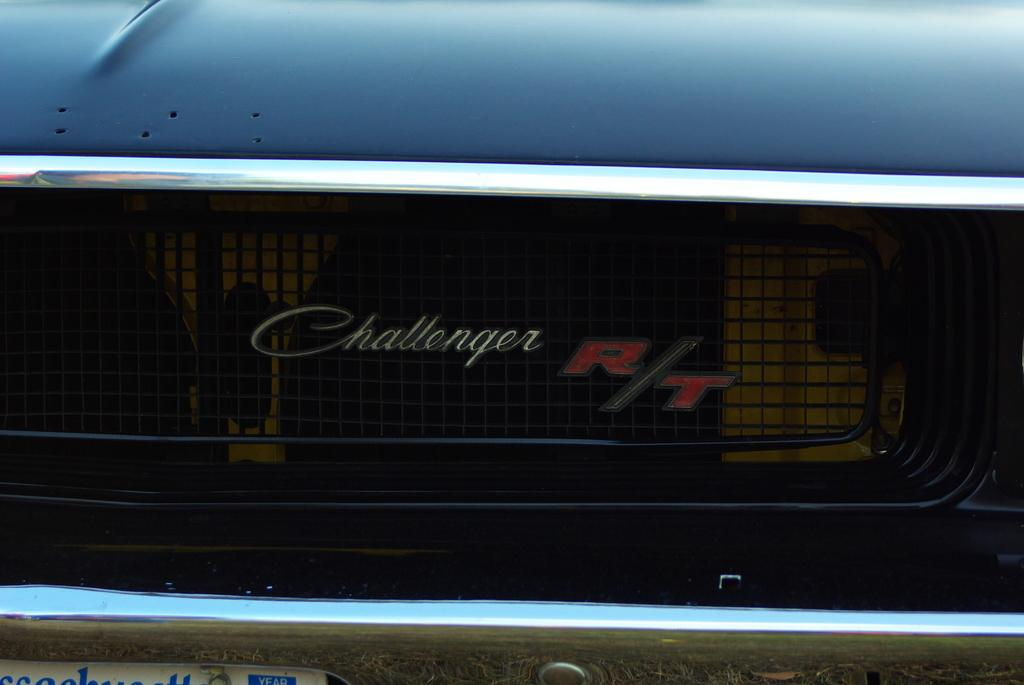What is the main subject of the image? The main subject of the image is a car. What part of the car is visible in the image? There is a nameplate and a bumper visible in the image. How many bulbs are hanging from the car in the image? There are no bulbs present in the image; it features a car with a nameplate and bumper. What type of fowl can be seen sitting on the car in the image? There is no fowl present in the image; it only features a car with a nameplate and bumper. 